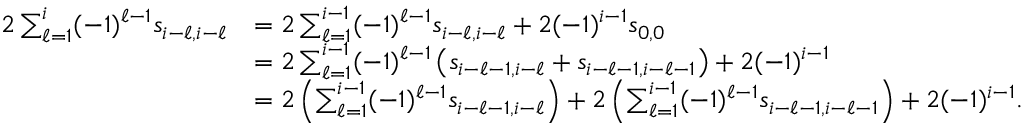<formula> <loc_0><loc_0><loc_500><loc_500>\begin{array} { r l } { 2 \sum _ { \ell = 1 } ^ { i } ( - 1 ) ^ { \ell - 1 } s _ { i - \ell , i - \ell } } & { = 2 \sum _ { \ell = 1 } ^ { i - 1 } ( - 1 ) ^ { \ell - 1 } s _ { i - \ell , i - \ell } + 2 ( - 1 ) ^ { i - 1 } s _ { 0 , 0 } } \\ & { = 2 \sum _ { \ell = 1 } ^ { i - 1 } ( - 1 ) ^ { \ell - 1 } \left ( s _ { i - \ell - 1 , i - \ell } + s _ { i - \ell - 1 , i - \ell - 1 } \right ) + 2 ( - 1 ) ^ { i - 1 } } \\ & { = 2 \left ( \sum _ { \ell = 1 } ^ { i - 1 } ( - 1 ) ^ { \ell - 1 } s _ { i - \ell - 1 , i - \ell } \right ) + 2 \left ( \sum _ { \ell = 1 } ^ { i - 1 } ( - 1 ) ^ { \ell - 1 } s _ { i - \ell - 1 , i - \ell - 1 } \right ) + 2 ( - 1 ) ^ { i - 1 } . } \end{array}</formula> 